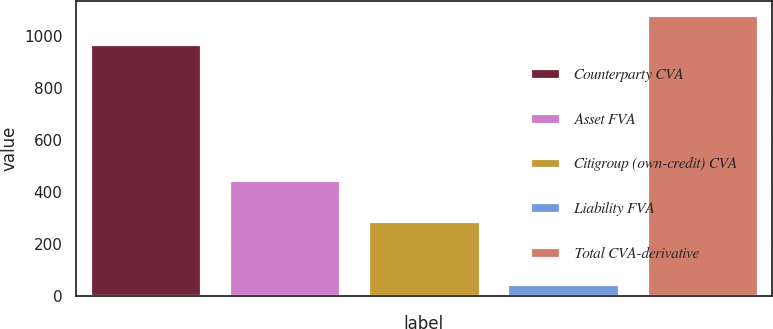<chart> <loc_0><loc_0><loc_500><loc_500><bar_chart><fcel>Counterparty CVA<fcel>Asset FVA<fcel>Citigroup (own-credit) CVA<fcel>Liability FVA<fcel>Total CVA-derivative<nl><fcel>970<fcel>447<fcel>287<fcel>47<fcel>1083<nl></chart> 